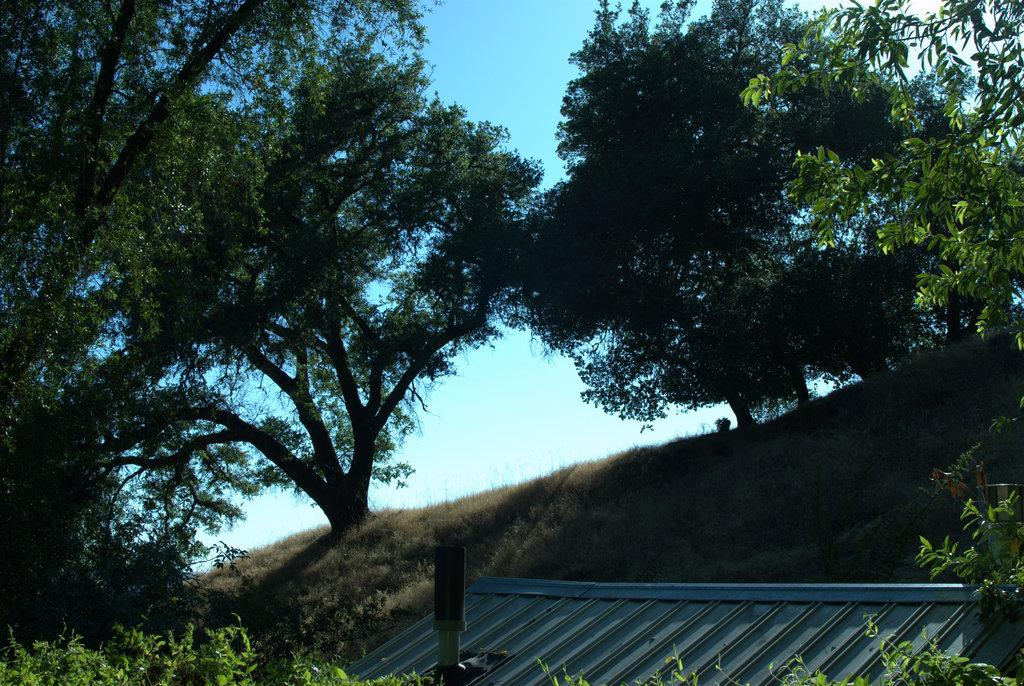What type of vegetation can be seen in the image? There are trees, plants, and grass in the image. What structure is visible at the bottom of the image? The roof of a shed is visible at the bottom of the image. What is visible at the top of the image? The sky is visible at the top of the image. How many carriages are being pushed by the trees in the image? There are no carriages present in the image, and the trees are not pushing anything. 